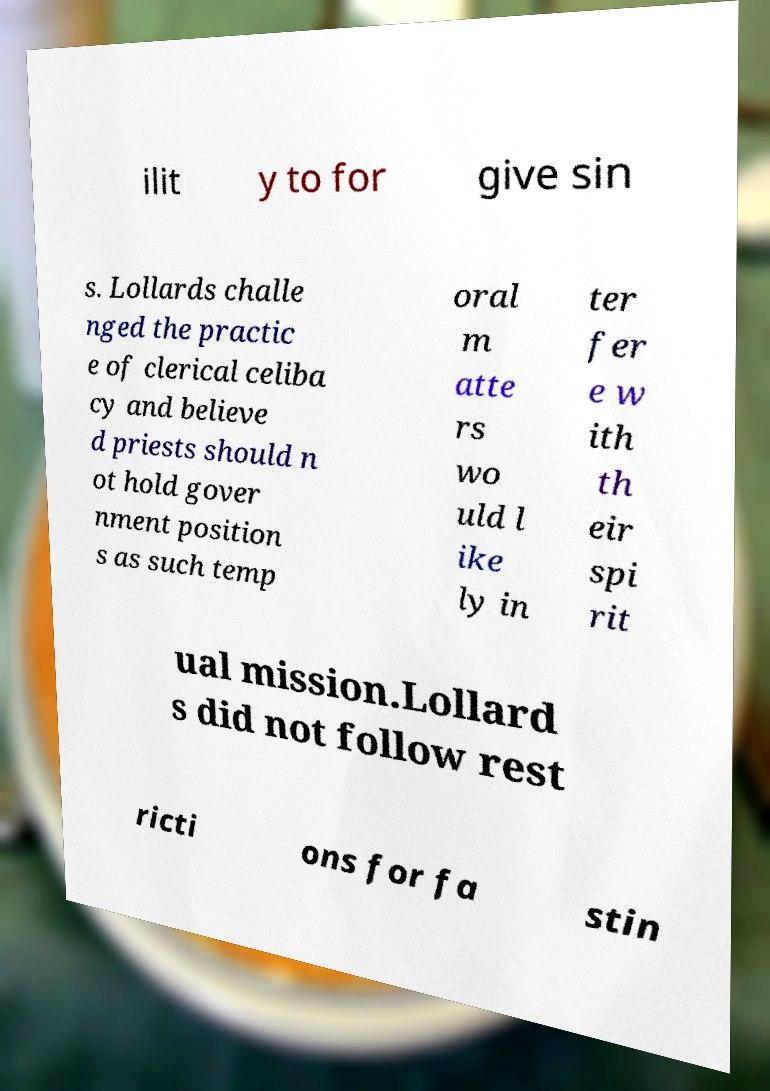Can you read and provide the text displayed in the image?This photo seems to have some interesting text. Can you extract and type it out for me? ilit y to for give sin s. Lollards challe nged the practic e of clerical celiba cy and believe d priests should n ot hold gover nment position s as such temp oral m atte rs wo uld l ike ly in ter fer e w ith th eir spi rit ual mission.Lollard s did not follow rest ricti ons for fa stin 